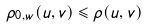Convert formula to latex. <formula><loc_0><loc_0><loc_500><loc_500>\rho _ { 0 , w } ( u , v ) \leqslant \rho ( u , v )</formula> 